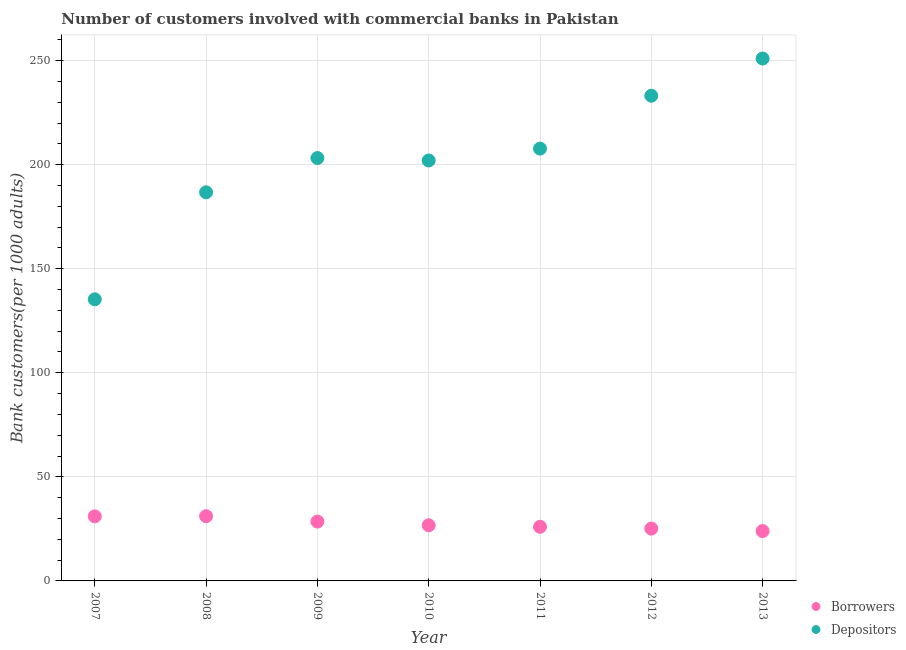What is the number of borrowers in 2007?
Offer a terse response. 31.01. Across all years, what is the maximum number of borrowers?
Offer a very short reply. 31.09. Across all years, what is the minimum number of borrowers?
Give a very brief answer. 23.97. In which year was the number of borrowers maximum?
Your response must be concise. 2008. What is the total number of depositors in the graph?
Make the answer very short. 1418.97. What is the difference between the number of borrowers in 2008 and that in 2011?
Provide a succinct answer. 5.08. What is the difference between the number of depositors in 2007 and the number of borrowers in 2009?
Offer a very short reply. 106.77. What is the average number of borrowers per year?
Provide a succinct answer. 27.5. In the year 2011, what is the difference between the number of borrowers and number of depositors?
Your answer should be very brief. -181.7. What is the ratio of the number of depositors in 2010 to that in 2011?
Give a very brief answer. 0.97. Is the difference between the number of depositors in 2007 and 2010 greater than the difference between the number of borrowers in 2007 and 2010?
Provide a succinct answer. No. What is the difference between the highest and the second highest number of depositors?
Give a very brief answer. 17.88. What is the difference between the highest and the lowest number of borrowers?
Your response must be concise. 7.13. Is the sum of the number of depositors in 2010 and 2012 greater than the maximum number of borrowers across all years?
Your response must be concise. Yes. Does the number of depositors monotonically increase over the years?
Give a very brief answer. No. Is the number of borrowers strictly greater than the number of depositors over the years?
Offer a terse response. No. How many dotlines are there?
Provide a succinct answer. 2. How many years are there in the graph?
Ensure brevity in your answer.  7. What is the difference between two consecutive major ticks on the Y-axis?
Your response must be concise. 50. Are the values on the major ticks of Y-axis written in scientific E-notation?
Keep it short and to the point. No. Where does the legend appear in the graph?
Your response must be concise. Bottom right. How are the legend labels stacked?
Keep it short and to the point. Vertical. What is the title of the graph?
Give a very brief answer. Number of customers involved with commercial banks in Pakistan. Does "Urban agglomerations" appear as one of the legend labels in the graph?
Make the answer very short. No. What is the label or title of the X-axis?
Your response must be concise. Year. What is the label or title of the Y-axis?
Make the answer very short. Bank customers(per 1000 adults). What is the Bank customers(per 1000 adults) of Borrowers in 2007?
Offer a very short reply. 31.01. What is the Bank customers(per 1000 adults) of Depositors in 2007?
Your answer should be compact. 135.29. What is the Bank customers(per 1000 adults) of Borrowers in 2008?
Keep it short and to the point. 31.09. What is the Bank customers(per 1000 adults) of Depositors in 2008?
Keep it short and to the point. 186.7. What is the Bank customers(per 1000 adults) of Borrowers in 2009?
Provide a succinct answer. 28.52. What is the Bank customers(per 1000 adults) in Depositors in 2009?
Your answer should be very brief. 203.17. What is the Bank customers(per 1000 adults) of Borrowers in 2010?
Ensure brevity in your answer.  26.73. What is the Bank customers(per 1000 adults) of Depositors in 2010?
Give a very brief answer. 202. What is the Bank customers(per 1000 adults) in Borrowers in 2011?
Ensure brevity in your answer.  26.01. What is the Bank customers(per 1000 adults) in Depositors in 2011?
Your answer should be compact. 207.71. What is the Bank customers(per 1000 adults) of Borrowers in 2012?
Offer a terse response. 25.15. What is the Bank customers(per 1000 adults) in Depositors in 2012?
Your answer should be very brief. 233.11. What is the Bank customers(per 1000 adults) in Borrowers in 2013?
Provide a succinct answer. 23.97. What is the Bank customers(per 1000 adults) of Depositors in 2013?
Ensure brevity in your answer.  250.99. Across all years, what is the maximum Bank customers(per 1000 adults) of Borrowers?
Your response must be concise. 31.09. Across all years, what is the maximum Bank customers(per 1000 adults) of Depositors?
Offer a terse response. 250.99. Across all years, what is the minimum Bank customers(per 1000 adults) in Borrowers?
Provide a short and direct response. 23.97. Across all years, what is the minimum Bank customers(per 1000 adults) in Depositors?
Your response must be concise. 135.29. What is the total Bank customers(per 1000 adults) of Borrowers in the graph?
Make the answer very short. 192.48. What is the total Bank customers(per 1000 adults) of Depositors in the graph?
Offer a terse response. 1418.97. What is the difference between the Bank customers(per 1000 adults) of Borrowers in 2007 and that in 2008?
Offer a very short reply. -0.08. What is the difference between the Bank customers(per 1000 adults) in Depositors in 2007 and that in 2008?
Offer a terse response. -51.41. What is the difference between the Bank customers(per 1000 adults) in Borrowers in 2007 and that in 2009?
Provide a short and direct response. 2.49. What is the difference between the Bank customers(per 1000 adults) in Depositors in 2007 and that in 2009?
Provide a short and direct response. -67.88. What is the difference between the Bank customers(per 1000 adults) in Borrowers in 2007 and that in 2010?
Offer a terse response. 4.29. What is the difference between the Bank customers(per 1000 adults) in Depositors in 2007 and that in 2010?
Give a very brief answer. -66.71. What is the difference between the Bank customers(per 1000 adults) in Borrowers in 2007 and that in 2011?
Ensure brevity in your answer.  5.01. What is the difference between the Bank customers(per 1000 adults) in Depositors in 2007 and that in 2011?
Keep it short and to the point. -72.42. What is the difference between the Bank customers(per 1000 adults) of Borrowers in 2007 and that in 2012?
Provide a short and direct response. 5.87. What is the difference between the Bank customers(per 1000 adults) in Depositors in 2007 and that in 2012?
Your answer should be very brief. -97.82. What is the difference between the Bank customers(per 1000 adults) in Borrowers in 2007 and that in 2013?
Your answer should be compact. 7.05. What is the difference between the Bank customers(per 1000 adults) of Depositors in 2007 and that in 2013?
Provide a short and direct response. -115.7. What is the difference between the Bank customers(per 1000 adults) of Borrowers in 2008 and that in 2009?
Offer a very short reply. 2.57. What is the difference between the Bank customers(per 1000 adults) of Depositors in 2008 and that in 2009?
Offer a very short reply. -16.47. What is the difference between the Bank customers(per 1000 adults) of Borrowers in 2008 and that in 2010?
Give a very brief answer. 4.36. What is the difference between the Bank customers(per 1000 adults) of Depositors in 2008 and that in 2010?
Your answer should be compact. -15.3. What is the difference between the Bank customers(per 1000 adults) in Borrowers in 2008 and that in 2011?
Offer a very short reply. 5.08. What is the difference between the Bank customers(per 1000 adults) of Depositors in 2008 and that in 2011?
Keep it short and to the point. -21.01. What is the difference between the Bank customers(per 1000 adults) in Borrowers in 2008 and that in 2012?
Make the answer very short. 5.94. What is the difference between the Bank customers(per 1000 adults) of Depositors in 2008 and that in 2012?
Keep it short and to the point. -46.41. What is the difference between the Bank customers(per 1000 adults) in Borrowers in 2008 and that in 2013?
Your answer should be compact. 7.13. What is the difference between the Bank customers(per 1000 adults) in Depositors in 2008 and that in 2013?
Make the answer very short. -64.29. What is the difference between the Bank customers(per 1000 adults) in Borrowers in 2009 and that in 2010?
Your answer should be very brief. 1.79. What is the difference between the Bank customers(per 1000 adults) of Depositors in 2009 and that in 2010?
Offer a very short reply. 1.17. What is the difference between the Bank customers(per 1000 adults) of Borrowers in 2009 and that in 2011?
Your response must be concise. 2.51. What is the difference between the Bank customers(per 1000 adults) of Depositors in 2009 and that in 2011?
Offer a very short reply. -4.54. What is the difference between the Bank customers(per 1000 adults) in Borrowers in 2009 and that in 2012?
Ensure brevity in your answer.  3.37. What is the difference between the Bank customers(per 1000 adults) of Depositors in 2009 and that in 2012?
Give a very brief answer. -29.94. What is the difference between the Bank customers(per 1000 adults) of Borrowers in 2009 and that in 2013?
Ensure brevity in your answer.  4.55. What is the difference between the Bank customers(per 1000 adults) of Depositors in 2009 and that in 2013?
Your answer should be compact. -47.82. What is the difference between the Bank customers(per 1000 adults) of Borrowers in 2010 and that in 2011?
Ensure brevity in your answer.  0.72. What is the difference between the Bank customers(per 1000 adults) of Depositors in 2010 and that in 2011?
Make the answer very short. -5.71. What is the difference between the Bank customers(per 1000 adults) in Borrowers in 2010 and that in 2012?
Your answer should be very brief. 1.58. What is the difference between the Bank customers(per 1000 adults) of Depositors in 2010 and that in 2012?
Offer a very short reply. -31.11. What is the difference between the Bank customers(per 1000 adults) of Borrowers in 2010 and that in 2013?
Offer a very short reply. 2.76. What is the difference between the Bank customers(per 1000 adults) of Depositors in 2010 and that in 2013?
Offer a very short reply. -49. What is the difference between the Bank customers(per 1000 adults) of Borrowers in 2011 and that in 2012?
Your answer should be very brief. 0.86. What is the difference between the Bank customers(per 1000 adults) of Depositors in 2011 and that in 2012?
Make the answer very short. -25.4. What is the difference between the Bank customers(per 1000 adults) in Borrowers in 2011 and that in 2013?
Give a very brief answer. 2.04. What is the difference between the Bank customers(per 1000 adults) in Depositors in 2011 and that in 2013?
Ensure brevity in your answer.  -43.28. What is the difference between the Bank customers(per 1000 adults) of Borrowers in 2012 and that in 2013?
Your response must be concise. 1.18. What is the difference between the Bank customers(per 1000 adults) of Depositors in 2012 and that in 2013?
Provide a succinct answer. -17.88. What is the difference between the Bank customers(per 1000 adults) of Borrowers in 2007 and the Bank customers(per 1000 adults) of Depositors in 2008?
Your response must be concise. -155.69. What is the difference between the Bank customers(per 1000 adults) in Borrowers in 2007 and the Bank customers(per 1000 adults) in Depositors in 2009?
Make the answer very short. -172.15. What is the difference between the Bank customers(per 1000 adults) of Borrowers in 2007 and the Bank customers(per 1000 adults) of Depositors in 2010?
Provide a succinct answer. -170.98. What is the difference between the Bank customers(per 1000 adults) of Borrowers in 2007 and the Bank customers(per 1000 adults) of Depositors in 2011?
Provide a short and direct response. -176.7. What is the difference between the Bank customers(per 1000 adults) in Borrowers in 2007 and the Bank customers(per 1000 adults) in Depositors in 2012?
Offer a very short reply. -202.09. What is the difference between the Bank customers(per 1000 adults) in Borrowers in 2007 and the Bank customers(per 1000 adults) in Depositors in 2013?
Your answer should be very brief. -219.98. What is the difference between the Bank customers(per 1000 adults) in Borrowers in 2008 and the Bank customers(per 1000 adults) in Depositors in 2009?
Your answer should be very brief. -172.08. What is the difference between the Bank customers(per 1000 adults) of Borrowers in 2008 and the Bank customers(per 1000 adults) of Depositors in 2010?
Provide a succinct answer. -170.91. What is the difference between the Bank customers(per 1000 adults) of Borrowers in 2008 and the Bank customers(per 1000 adults) of Depositors in 2011?
Provide a succinct answer. -176.62. What is the difference between the Bank customers(per 1000 adults) in Borrowers in 2008 and the Bank customers(per 1000 adults) in Depositors in 2012?
Your response must be concise. -202.02. What is the difference between the Bank customers(per 1000 adults) in Borrowers in 2008 and the Bank customers(per 1000 adults) in Depositors in 2013?
Your response must be concise. -219.9. What is the difference between the Bank customers(per 1000 adults) in Borrowers in 2009 and the Bank customers(per 1000 adults) in Depositors in 2010?
Provide a short and direct response. -173.48. What is the difference between the Bank customers(per 1000 adults) of Borrowers in 2009 and the Bank customers(per 1000 adults) of Depositors in 2011?
Provide a succinct answer. -179.19. What is the difference between the Bank customers(per 1000 adults) in Borrowers in 2009 and the Bank customers(per 1000 adults) in Depositors in 2012?
Your response must be concise. -204.59. What is the difference between the Bank customers(per 1000 adults) of Borrowers in 2009 and the Bank customers(per 1000 adults) of Depositors in 2013?
Offer a terse response. -222.47. What is the difference between the Bank customers(per 1000 adults) of Borrowers in 2010 and the Bank customers(per 1000 adults) of Depositors in 2011?
Offer a terse response. -180.98. What is the difference between the Bank customers(per 1000 adults) of Borrowers in 2010 and the Bank customers(per 1000 adults) of Depositors in 2012?
Your answer should be compact. -206.38. What is the difference between the Bank customers(per 1000 adults) in Borrowers in 2010 and the Bank customers(per 1000 adults) in Depositors in 2013?
Provide a short and direct response. -224.26. What is the difference between the Bank customers(per 1000 adults) in Borrowers in 2011 and the Bank customers(per 1000 adults) in Depositors in 2012?
Offer a terse response. -207.1. What is the difference between the Bank customers(per 1000 adults) in Borrowers in 2011 and the Bank customers(per 1000 adults) in Depositors in 2013?
Your answer should be very brief. -224.98. What is the difference between the Bank customers(per 1000 adults) of Borrowers in 2012 and the Bank customers(per 1000 adults) of Depositors in 2013?
Ensure brevity in your answer.  -225.85. What is the average Bank customers(per 1000 adults) in Borrowers per year?
Your response must be concise. 27.5. What is the average Bank customers(per 1000 adults) of Depositors per year?
Give a very brief answer. 202.71. In the year 2007, what is the difference between the Bank customers(per 1000 adults) in Borrowers and Bank customers(per 1000 adults) in Depositors?
Provide a succinct answer. -104.28. In the year 2008, what is the difference between the Bank customers(per 1000 adults) of Borrowers and Bank customers(per 1000 adults) of Depositors?
Give a very brief answer. -155.61. In the year 2009, what is the difference between the Bank customers(per 1000 adults) in Borrowers and Bank customers(per 1000 adults) in Depositors?
Make the answer very short. -174.65. In the year 2010, what is the difference between the Bank customers(per 1000 adults) of Borrowers and Bank customers(per 1000 adults) of Depositors?
Offer a very short reply. -175.27. In the year 2011, what is the difference between the Bank customers(per 1000 adults) of Borrowers and Bank customers(per 1000 adults) of Depositors?
Your response must be concise. -181.7. In the year 2012, what is the difference between the Bank customers(per 1000 adults) of Borrowers and Bank customers(per 1000 adults) of Depositors?
Give a very brief answer. -207.96. In the year 2013, what is the difference between the Bank customers(per 1000 adults) in Borrowers and Bank customers(per 1000 adults) in Depositors?
Your response must be concise. -227.03. What is the ratio of the Bank customers(per 1000 adults) in Borrowers in 2007 to that in 2008?
Keep it short and to the point. 1. What is the ratio of the Bank customers(per 1000 adults) of Depositors in 2007 to that in 2008?
Provide a short and direct response. 0.72. What is the ratio of the Bank customers(per 1000 adults) of Borrowers in 2007 to that in 2009?
Ensure brevity in your answer.  1.09. What is the ratio of the Bank customers(per 1000 adults) in Depositors in 2007 to that in 2009?
Provide a short and direct response. 0.67. What is the ratio of the Bank customers(per 1000 adults) of Borrowers in 2007 to that in 2010?
Your response must be concise. 1.16. What is the ratio of the Bank customers(per 1000 adults) of Depositors in 2007 to that in 2010?
Provide a short and direct response. 0.67. What is the ratio of the Bank customers(per 1000 adults) in Borrowers in 2007 to that in 2011?
Your answer should be very brief. 1.19. What is the ratio of the Bank customers(per 1000 adults) in Depositors in 2007 to that in 2011?
Make the answer very short. 0.65. What is the ratio of the Bank customers(per 1000 adults) of Borrowers in 2007 to that in 2012?
Provide a short and direct response. 1.23. What is the ratio of the Bank customers(per 1000 adults) of Depositors in 2007 to that in 2012?
Provide a succinct answer. 0.58. What is the ratio of the Bank customers(per 1000 adults) in Borrowers in 2007 to that in 2013?
Provide a short and direct response. 1.29. What is the ratio of the Bank customers(per 1000 adults) in Depositors in 2007 to that in 2013?
Make the answer very short. 0.54. What is the ratio of the Bank customers(per 1000 adults) of Borrowers in 2008 to that in 2009?
Keep it short and to the point. 1.09. What is the ratio of the Bank customers(per 1000 adults) of Depositors in 2008 to that in 2009?
Your answer should be compact. 0.92. What is the ratio of the Bank customers(per 1000 adults) in Borrowers in 2008 to that in 2010?
Provide a succinct answer. 1.16. What is the ratio of the Bank customers(per 1000 adults) of Depositors in 2008 to that in 2010?
Make the answer very short. 0.92. What is the ratio of the Bank customers(per 1000 adults) of Borrowers in 2008 to that in 2011?
Your answer should be very brief. 1.2. What is the ratio of the Bank customers(per 1000 adults) in Depositors in 2008 to that in 2011?
Offer a terse response. 0.9. What is the ratio of the Bank customers(per 1000 adults) of Borrowers in 2008 to that in 2012?
Ensure brevity in your answer.  1.24. What is the ratio of the Bank customers(per 1000 adults) in Depositors in 2008 to that in 2012?
Your response must be concise. 0.8. What is the ratio of the Bank customers(per 1000 adults) in Borrowers in 2008 to that in 2013?
Your response must be concise. 1.3. What is the ratio of the Bank customers(per 1000 adults) in Depositors in 2008 to that in 2013?
Give a very brief answer. 0.74. What is the ratio of the Bank customers(per 1000 adults) of Borrowers in 2009 to that in 2010?
Provide a succinct answer. 1.07. What is the ratio of the Bank customers(per 1000 adults) in Depositors in 2009 to that in 2010?
Provide a succinct answer. 1.01. What is the ratio of the Bank customers(per 1000 adults) of Borrowers in 2009 to that in 2011?
Your answer should be compact. 1.1. What is the ratio of the Bank customers(per 1000 adults) of Depositors in 2009 to that in 2011?
Your response must be concise. 0.98. What is the ratio of the Bank customers(per 1000 adults) in Borrowers in 2009 to that in 2012?
Your answer should be very brief. 1.13. What is the ratio of the Bank customers(per 1000 adults) in Depositors in 2009 to that in 2012?
Give a very brief answer. 0.87. What is the ratio of the Bank customers(per 1000 adults) of Borrowers in 2009 to that in 2013?
Make the answer very short. 1.19. What is the ratio of the Bank customers(per 1000 adults) in Depositors in 2009 to that in 2013?
Your response must be concise. 0.81. What is the ratio of the Bank customers(per 1000 adults) in Borrowers in 2010 to that in 2011?
Make the answer very short. 1.03. What is the ratio of the Bank customers(per 1000 adults) of Depositors in 2010 to that in 2011?
Make the answer very short. 0.97. What is the ratio of the Bank customers(per 1000 adults) of Borrowers in 2010 to that in 2012?
Provide a succinct answer. 1.06. What is the ratio of the Bank customers(per 1000 adults) of Depositors in 2010 to that in 2012?
Ensure brevity in your answer.  0.87. What is the ratio of the Bank customers(per 1000 adults) in Borrowers in 2010 to that in 2013?
Offer a terse response. 1.12. What is the ratio of the Bank customers(per 1000 adults) in Depositors in 2010 to that in 2013?
Give a very brief answer. 0.8. What is the ratio of the Bank customers(per 1000 adults) in Borrowers in 2011 to that in 2012?
Keep it short and to the point. 1.03. What is the ratio of the Bank customers(per 1000 adults) of Depositors in 2011 to that in 2012?
Your answer should be very brief. 0.89. What is the ratio of the Bank customers(per 1000 adults) of Borrowers in 2011 to that in 2013?
Provide a succinct answer. 1.09. What is the ratio of the Bank customers(per 1000 adults) of Depositors in 2011 to that in 2013?
Your answer should be very brief. 0.83. What is the ratio of the Bank customers(per 1000 adults) of Borrowers in 2012 to that in 2013?
Give a very brief answer. 1.05. What is the ratio of the Bank customers(per 1000 adults) in Depositors in 2012 to that in 2013?
Give a very brief answer. 0.93. What is the difference between the highest and the second highest Bank customers(per 1000 adults) of Borrowers?
Your answer should be very brief. 0.08. What is the difference between the highest and the second highest Bank customers(per 1000 adults) of Depositors?
Give a very brief answer. 17.88. What is the difference between the highest and the lowest Bank customers(per 1000 adults) of Borrowers?
Your answer should be very brief. 7.13. What is the difference between the highest and the lowest Bank customers(per 1000 adults) of Depositors?
Your answer should be very brief. 115.7. 